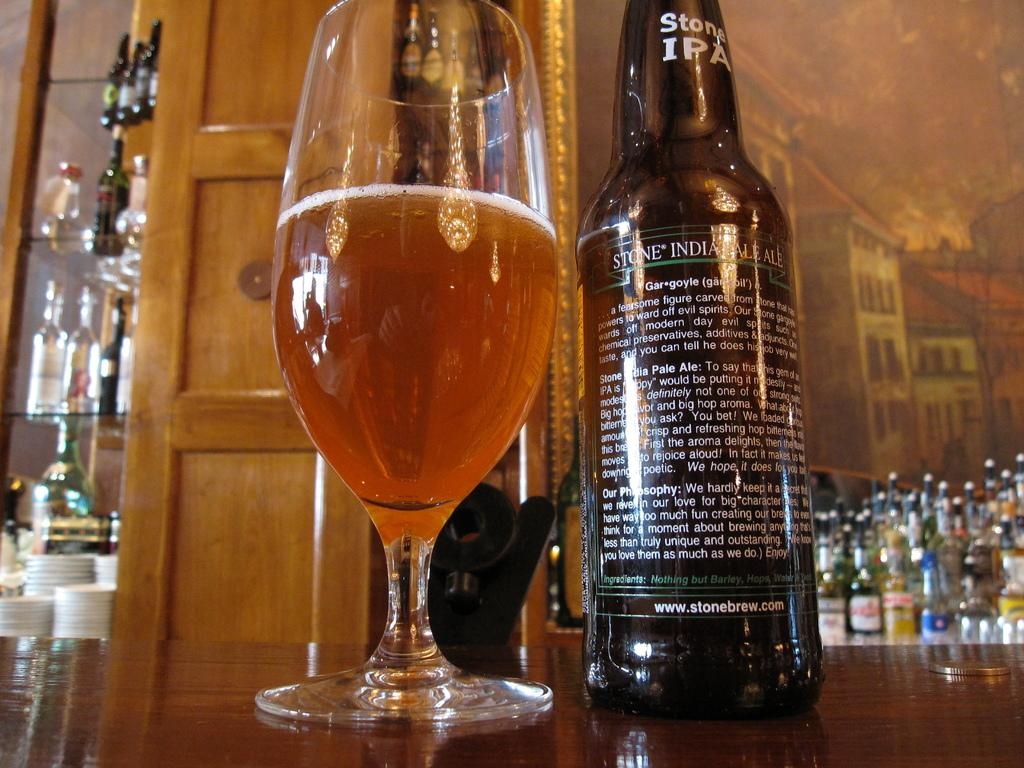What can be seen in the image that is used for holding liquids? There is a bottle and a glass with a drink in the image. Where are the bottle and glass located in the image? Both the bottle and glass are placed on a table. What can be seen in the background of the image? There are bottles and a wall in the background of the image. Are there any architectural features visible in the background? Yes, there is a door in the background of the image. What type of gold jewelry is being worn by the people in the image? There are no people visible in the image, and therefore no jewelry can be observed. 